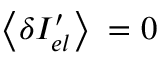<formula> <loc_0><loc_0><loc_500><loc_500>\left \langle \delta { { I } _ { e l } ^ { \prime } } \right \rangle = 0</formula> 